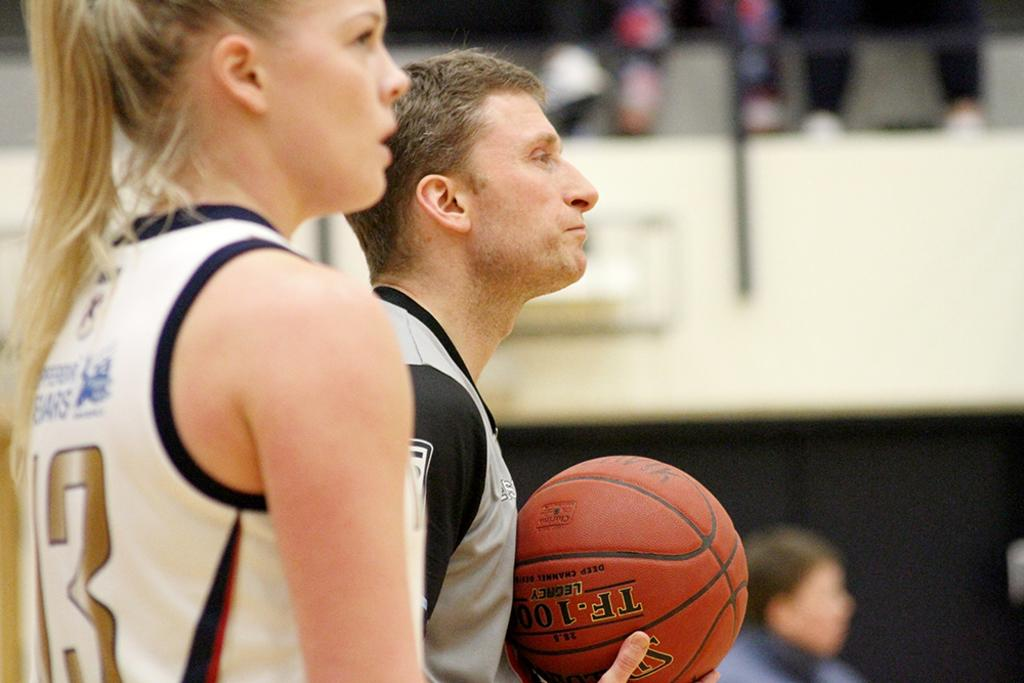<image>
Describe the image concisely. A man and women are playing basketball and the girl's jersey has the number 13 on it. 